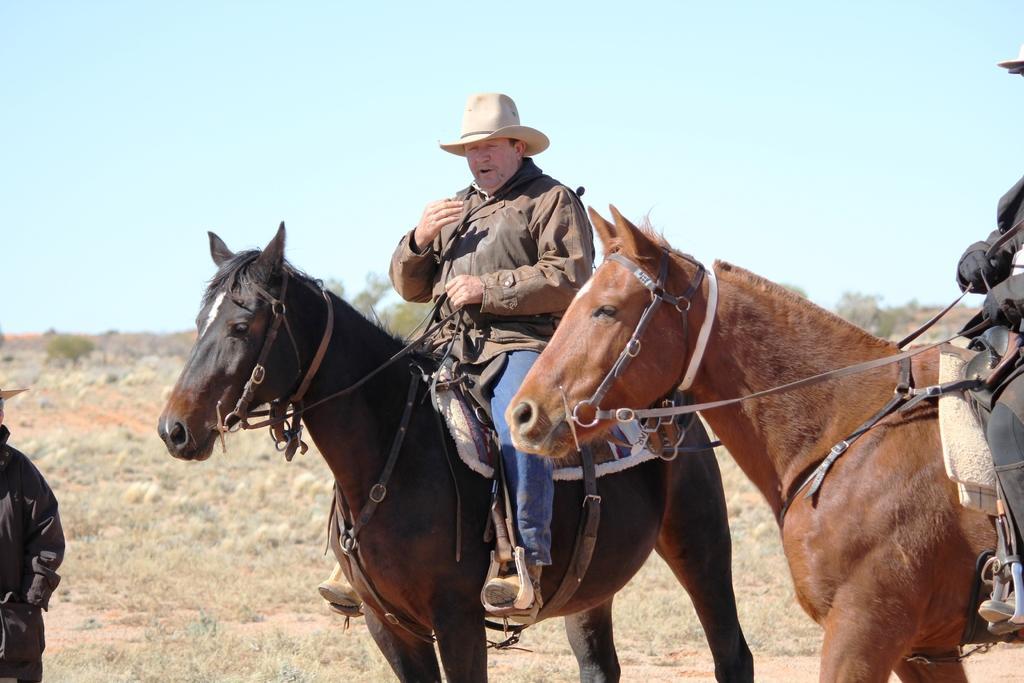Describe this image in one or two sentences. The person wearing hat is sitting on a horse and there is another person sitting on a horse beside him and there is a person standing in the left corner. 